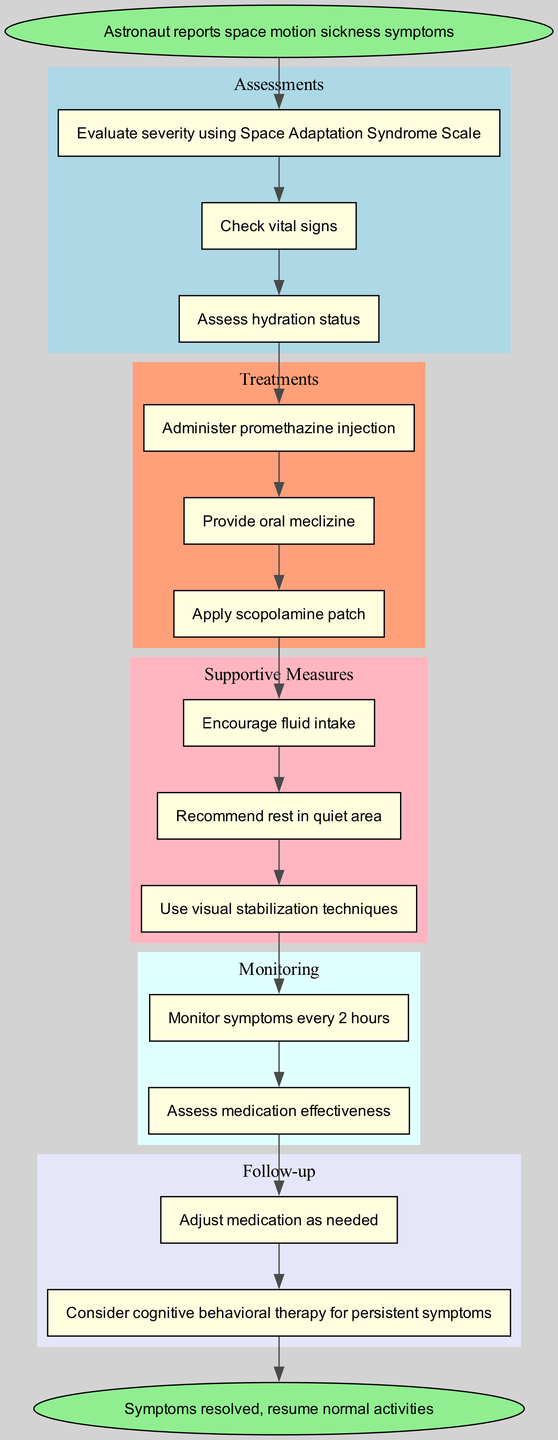What is the first step when an astronaut reports symptoms? The first step in the diagram is connecting the "start" node to the first assessment node, which tackles the evaluation of space motion sickness symptoms.
Answer: Evaluate severity using Space Adaptation Syndrome Scale How many treatments are listed in the pathway? By counting the treatment nodes present in the "Treatments" section of the diagram, we find there are a total of three treatments outlined.
Answer: 3 What follows after assessments are completed? The flow from the last assessment node directly connects to the first treatment node, indicating that treatments commence immediately after assessments are completed.
Answer: Administer promethazine injection Which supportive measure is recommended first? The first supportive measure listed after the treatments section helps to ensure hydration and support for the astronaut, marking it as the first focus for supportive measures.
Answer: Encourage fluid intake What is the timing for monitoring symptoms? Monitoring instructions specify that symptoms should be tracked every two hours, highlighting the specific interval for observation in the clinical pathway diagram.
Answer: Every 2 hours What should happen if symptoms persist after medication? The follow-up section suggests adjusting medication or considering additional therapy for astronauts who still have symptoms, indicating a second chance for recovery intervention.
Answer: Consider cognitive behavioral therapy for persistent symptoms How many nodes are there in the monitoring section? The enumeration of the monitoring activities reveals there are two distinct nodes dedicated to the monitoring process for evaluating symptoms and medications.
Answer: 2 Describe the connection between treatment and supportive measures. The arrow labeled between the last treatment node and the first supportive measure node signifies that supportive measures are initiated directly after all treatments have been administered.
Answer: Apply scopolamine patch 